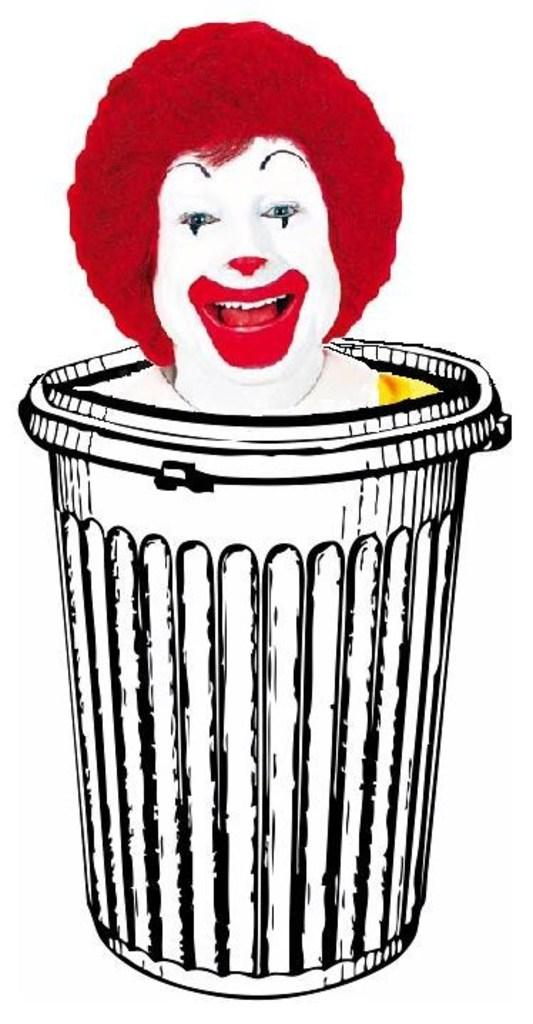What is the main subject of the image? There is a painting in the image. What is depicted in the painting? The painting depicts a basket. Are there any figures or objects inside the basket in the painting? Yes, there is a person with a joker face inside the basket in the painting. What color is the background of the painting? The background of the painting is white. What type of skin can be seen on the person's face in the painting? There is no specific type of skin mentioned or visible on the person's face in the painting; it is a joker face depicted in the image. Where is the pail located in the painting? There is no pail present in the painting; it depicts a basket with a person inside. 